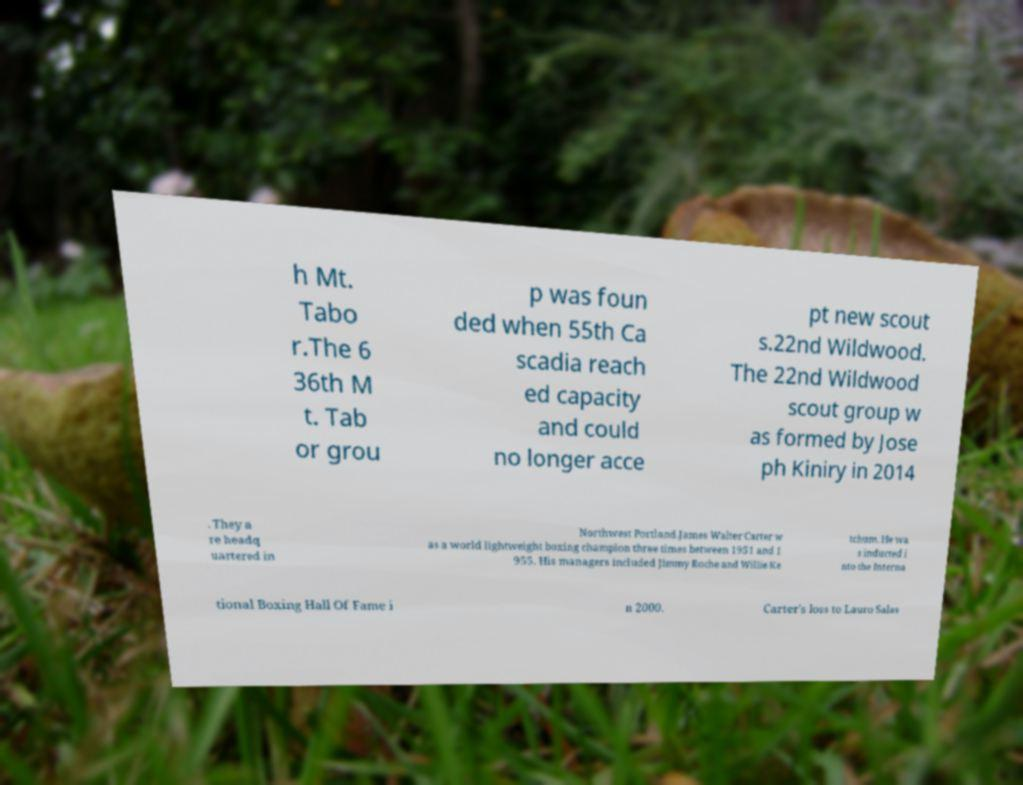What messages or text are displayed in this image? I need them in a readable, typed format. h Mt. Tabo r.The 6 36th M t. Tab or grou p was foun ded when 55th Ca scadia reach ed capacity and could no longer acce pt new scout s.22nd Wildwood. The 22nd Wildwood scout group w as formed by Jose ph Kiniry in 2014 . They a re headq uartered in Northwest Portland.James Walter Carter w as a world lightweight boxing champion three times between 1951 and 1 955. His managers included Jimmy Roche and Willie Ke tchum. He wa s inducted i nto the Interna tional Boxing Hall Of Fame i n 2000. Carter's loss to Lauro Salas 